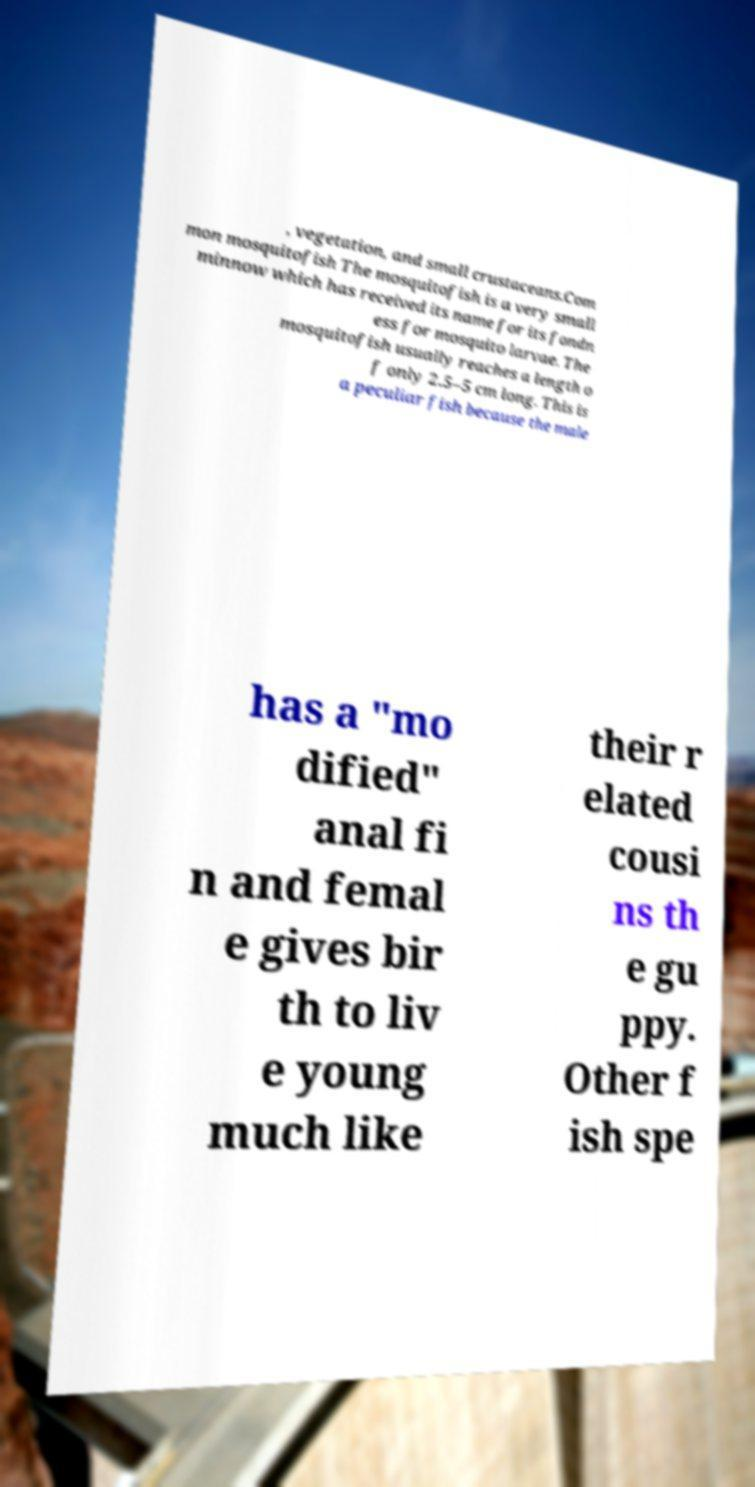Can you read and provide the text displayed in the image?This photo seems to have some interesting text. Can you extract and type it out for me? , vegetation, and small crustaceans.Com mon mosquitofish The mosquitofish is a very small minnow which has received its name for its fondn ess for mosquito larvae. The mosquitofish usually reaches a length o f only 2.5–5 cm long. This is a peculiar fish because the male has a "mo dified" anal fi n and femal e gives bir th to liv e young much like their r elated cousi ns th e gu ppy. Other f ish spe 